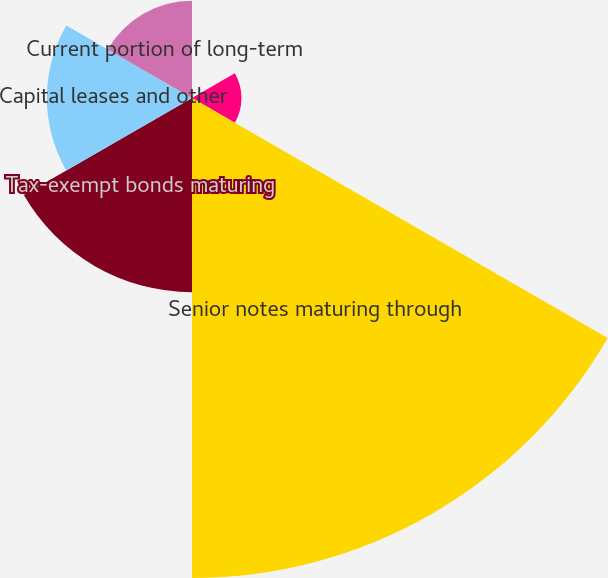Convert chart. <chart><loc_0><loc_0><loc_500><loc_500><pie_chart><fcel>225 billion revolving credit<fcel>Canadian term loan and<fcel>Senior notes maturing through<fcel>Tax-exempt bonds maturing<fcel>Capital leases and other<fcel>Current portion of long-term<nl><fcel>0.16%<fcel>5.11%<fcel>49.61%<fcel>20.07%<fcel>15.0%<fcel>10.05%<nl></chart> 